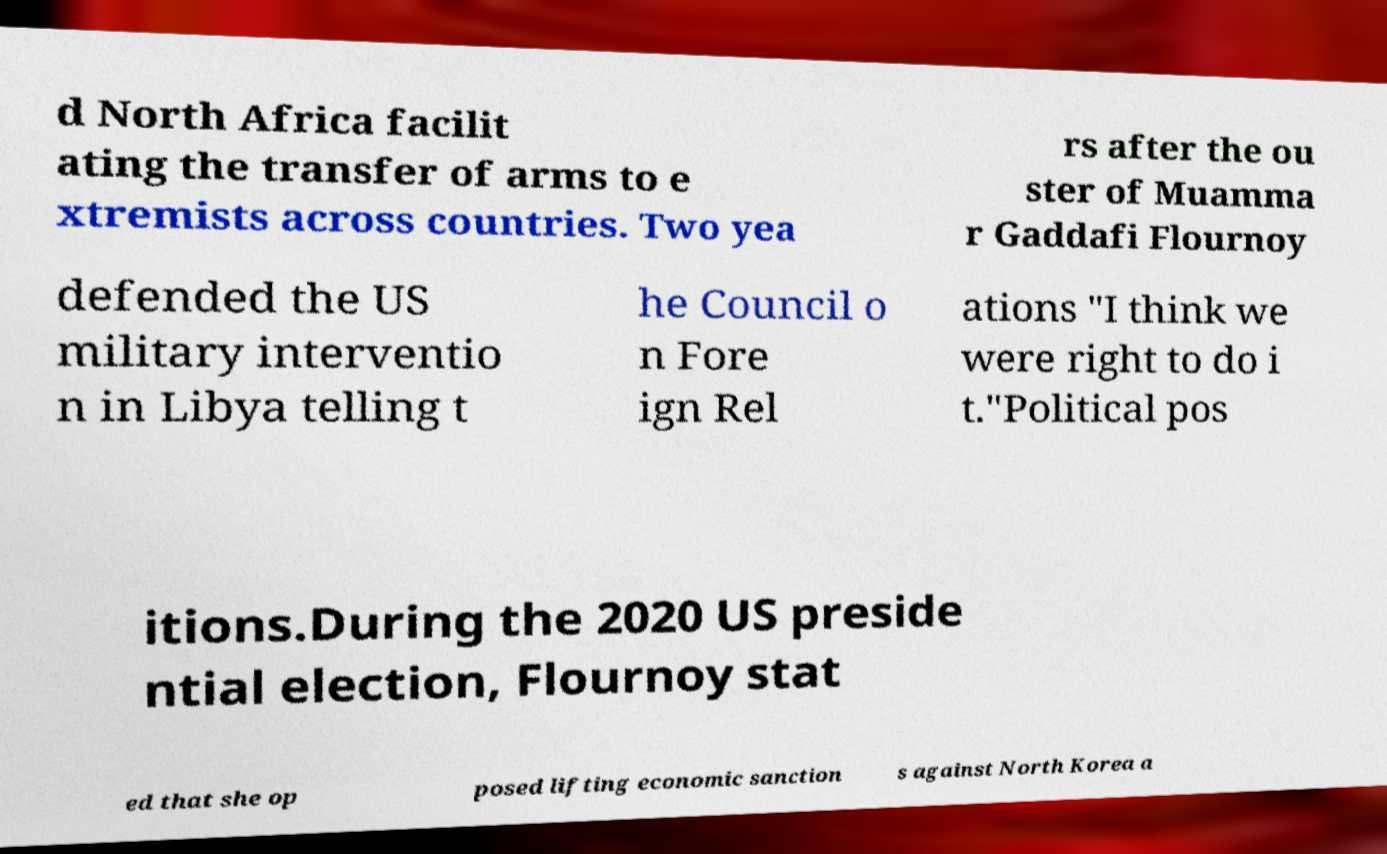Could you extract and type out the text from this image? d North Africa facilit ating the transfer of arms to e xtremists across countries. Two yea rs after the ou ster of Muamma r Gaddafi Flournoy defended the US military interventio n in Libya telling t he Council o n Fore ign Rel ations "I think we were right to do i t."Political pos itions.During the 2020 US preside ntial election, Flournoy stat ed that she op posed lifting economic sanction s against North Korea a 